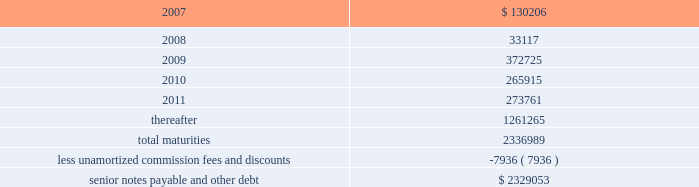Ventas , inc .
Notes to consolidated financial statements 2014 ( continued ) if we experience certain kinds of changes of control , the issuers must make an offer to repurchase the senior notes , in whole or in part , at a purchase price in cash equal to 101% ( 101 % ) of the principal amount of the senior notes , plus any accrued and unpaid interest to the date of purchase ; provided , however , that in the event moody 2019s and s&p have confirmed their ratings at ba3 or higher and bb- or higher on the senior notes and certain other conditions are met , this repurchase obligation will not apply .
Mortgages at december 31 , 2006 , we had outstanding 53 mortgage loans that we assumed in connection with various acquisitions .
Outstanding principal balances on these loans ranged from $ 0.4 million to $ 114.4 million as of december 31 , 2006 .
The loans bear interest at fixed rates ranging from 5.6% ( 5.6 % ) to 8.5% ( 8.5 % ) per annum , except with respect to eight loans with outstanding principal balances ranging from $ 0.4 million to $ 114.4 million , which bear interest at the lender 2019s variable rates , ranging from 3.6% ( 3.6 % ) to 8.5% ( 8.5 % ) per annum at of december 31 , 2006 .
The fixed rate debt bears interest at a weighted average annual rate of 7.06% ( 7.06 % ) and the variable rate debt bears interest at a weighted average annual rate of 5.61% ( 5.61 % ) as of december 31 , 2006 .
The loans had a weighted average maturity of eight years as of december 31 , 2006 .
The $ 114.4 variable mortgage debt was repaid in january 2007 .
Scheduled maturities of borrowing arrangements and other provisions as of december 31 , 2006 , our indebtedness has the following maturities ( in thousands ) : .
Certain provisions of our long-term debt contain covenants that limit our ability and the ability of certain of our subsidiaries to , among other things : ( i ) incur debt ; ( ii ) make certain dividends , distributions and investments ; ( iii ) enter into certain transactions ; ( iv ) merge , consolidate or transfer certain assets ; and ( v ) sell assets .
We and certain of our subsidiaries are also required to maintain total unencumbered assets of at least 150% ( 150 % ) of this group 2019s unsecured debt .
Derivatives and hedging in the normal course of business , we are exposed to the effect of interest rate changes .
We limit these risks by following established risk management policies and procedures including the use of derivatives .
For interest rate exposures , derivatives are used primarily to fix the rate on debt based on floating-rate indices and to manage the cost of borrowing obligations .
We currently have an interest rate swap to manage interest rate risk ( the 201cswap 201d ) .
We prohibit the use of derivative instruments for trading or speculative purposes .
Further , we have a policy of only entering into contracts with major financial institutions based upon their credit ratings and other factors .
When viewed in conjunction with the underlying and offsetting exposure that the derivative is designed to hedge , we do not anticipate any material adverse effect on our net income or financial position in the future from the use of derivatives. .
What was the percent of growth in maturities from 2009 to 2010? 
Rationale: the growth rate is the change from period to period divided by the original amount
Computations: ((265915 - 372725) / 265915)
Answer: -0.40167. 